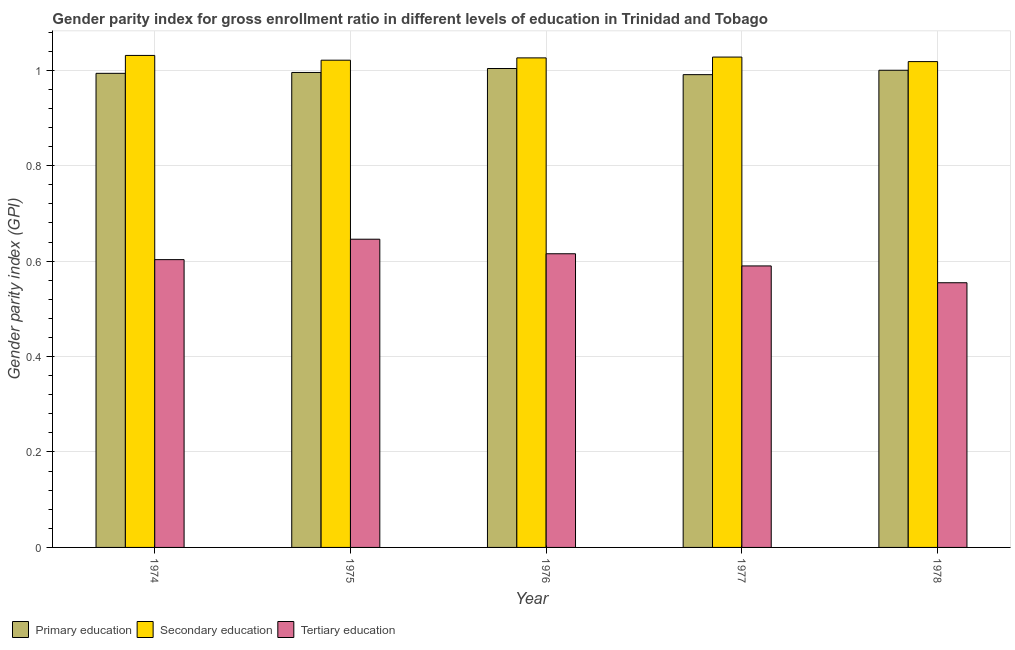How many different coloured bars are there?
Your answer should be compact. 3. Are the number of bars on each tick of the X-axis equal?
Offer a terse response. Yes. How many bars are there on the 1st tick from the left?
Ensure brevity in your answer.  3. How many bars are there on the 2nd tick from the right?
Give a very brief answer. 3. What is the label of the 5th group of bars from the left?
Your answer should be compact. 1978. In how many cases, is the number of bars for a given year not equal to the number of legend labels?
Provide a short and direct response. 0. What is the gender parity index in tertiary education in 1978?
Provide a succinct answer. 0.55. Across all years, what is the maximum gender parity index in primary education?
Keep it short and to the point. 1. Across all years, what is the minimum gender parity index in primary education?
Provide a succinct answer. 0.99. In which year was the gender parity index in primary education maximum?
Your answer should be very brief. 1976. In which year was the gender parity index in secondary education minimum?
Your answer should be very brief. 1978. What is the total gender parity index in tertiary education in the graph?
Offer a very short reply. 3.01. What is the difference between the gender parity index in primary education in 1974 and that in 1976?
Make the answer very short. -0.01. What is the difference between the gender parity index in tertiary education in 1974 and the gender parity index in primary education in 1976?
Your answer should be very brief. -0.01. What is the average gender parity index in primary education per year?
Offer a terse response. 1. What is the ratio of the gender parity index in secondary education in 1974 to that in 1977?
Your answer should be compact. 1. Is the difference between the gender parity index in secondary education in 1976 and 1977 greater than the difference between the gender parity index in primary education in 1976 and 1977?
Provide a succinct answer. No. What is the difference between the highest and the second highest gender parity index in primary education?
Ensure brevity in your answer.  0. What is the difference between the highest and the lowest gender parity index in secondary education?
Provide a short and direct response. 0.01. Is the sum of the gender parity index in primary education in 1974 and 1975 greater than the maximum gender parity index in tertiary education across all years?
Your response must be concise. Yes. What does the 3rd bar from the left in 1978 represents?
Provide a succinct answer. Tertiary education. What does the 2nd bar from the right in 1976 represents?
Provide a succinct answer. Secondary education. How many bars are there?
Ensure brevity in your answer.  15. Are all the bars in the graph horizontal?
Your response must be concise. No. What is the difference between two consecutive major ticks on the Y-axis?
Keep it short and to the point. 0.2. Are the values on the major ticks of Y-axis written in scientific E-notation?
Your answer should be very brief. No. Does the graph contain grids?
Make the answer very short. Yes. What is the title of the graph?
Offer a very short reply. Gender parity index for gross enrollment ratio in different levels of education in Trinidad and Tobago. Does "Ages 15-20" appear as one of the legend labels in the graph?
Give a very brief answer. No. What is the label or title of the X-axis?
Your response must be concise. Year. What is the label or title of the Y-axis?
Make the answer very short. Gender parity index (GPI). What is the Gender parity index (GPI) in Primary education in 1974?
Keep it short and to the point. 0.99. What is the Gender parity index (GPI) in Secondary education in 1974?
Provide a short and direct response. 1.03. What is the Gender parity index (GPI) of Tertiary education in 1974?
Your response must be concise. 0.6. What is the Gender parity index (GPI) in Secondary education in 1975?
Ensure brevity in your answer.  1.02. What is the Gender parity index (GPI) in Tertiary education in 1975?
Your answer should be compact. 0.65. What is the Gender parity index (GPI) of Secondary education in 1976?
Your answer should be compact. 1.03. What is the Gender parity index (GPI) in Tertiary education in 1976?
Make the answer very short. 0.62. What is the Gender parity index (GPI) of Primary education in 1977?
Keep it short and to the point. 0.99. What is the Gender parity index (GPI) of Secondary education in 1977?
Provide a short and direct response. 1.03. What is the Gender parity index (GPI) in Tertiary education in 1977?
Offer a very short reply. 0.59. What is the Gender parity index (GPI) in Primary education in 1978?
Offer a very short reply. 1. What is the Gender parity index (GPI) in Secondary education in 1978?
Provide a short and direct response. 1.02. What is the Gender parity index (GPI) of Tertiary education in 1978?
Offer a terse response. 0.55. Across all years, what is the maximum Gender parity index (GPI) in Primary education?
Provide a succinct answer. 1. Across all years, what is the maximum Gender parity index (GPI) in Secondary education?
Provide a succinct answer. 1.03. Across all years, what is the maximum Gender parity index (GPI) of Tertiary education?
Ensure brevity in your answer.  0.65. Across all years, what is the minimum Gender parity index (GPI) of Primary education?
Provide a succinct answer. 0.99. Across all years, what is the minimum Gender parity index (GPI) in Secondary education?
Offer a very short reply. 1.02. Across all years, what is the minimum Gender parity index (GPI) in Tertiary education?
Your answer should be compact. 0.55. What is the total Gender parity index (GPI) in Primary education in the graph?
Make the answer very short. 4.98. What is the total Gender parity index (GPI) of Secondary education in the graph?
Make the answer very short. 5.12. What is the total Gender parity index (GPI) in Tertiary education in the graph?
Provide a short and direct response. 3.01. What is the difference between the Gender parity index (GPI) of Primary education in 1974 and that in 1975?
Ensure brevity in your answer.  -0. What is the difference between the Gender parity index (GPI) in Secondary education in 1974 and that in 1975?
Ensure brevity in your answer.  0.01. What is the difference between the Gender parity index (GPI) of Tertiary education in 1974 and that in 1975?
Your answer should be compact. -0.04. What is the difference between the Gender parity index (GPI) in Primary education in 1974 and that in 1976?
Offer a terse response. -0.01. What is the difference between the Gender parity index (GPI) in Secondary education in 1974 and that in 1976?
Give a very brief answer. 0.01. What is the difference between the Gender parity index (GPI) in Tertiary education in 1974 and that in 1976?
Keep it short and to the point. -0.01. What is the difference between the Gender parity index (GPI) in Primary education in 1974 and that in 1977?
Provide a succinct answer. 0. What is the difference between the Gender parity index (GPI) in Secondary education in 1974 and that in 1977?
Offer a terse response. 0. What is the difference between the Gender parity index (GPI) in Tertiary education in 1974 and that in 1977?
Ensure brevity in your answer.  0.01. What is the difference between the Gender parity index (GPI) of Primary education in 1974 and that in 1978?
Your response must be concise. -0.01. What is the difference between the Gender parity index (GPI) in Secondary education in 1974 and that in 1978?
Your response must be concise. 0.01. What is the difference between the Gender parity index (GPI) of Tertiary education in 1974 and that in 1978?
Offer a terse response. 0.05. What is the difference between the Gender parity index (GPI) in Primary education in 1975 and that in 1976?
Offer a terse response. -0.01. What is the difference between the Gender parity index (GPI) of Secondary education in 1975 and that in 1976?
Your answer should be compact. -0. What is the difference between the Gender parity index (GPI) of Tertiary education in 1975 and that in 1976?
Your answer should be compact. 0.03. What is the difference between the Gender parity index (GPI) in Primary education in 1975 and that in 1977?
Your response must be concise. 0. What is the difference between the Gender parity index (GPI) in Secondary education in 1975 and that in 1977?
Give a very brief answer. -0.01. What is the difference between the Gender parity index (GPI) of Tertiary education in 1975 and that in 1977?
Ensure brevity in your answer.  0.06. What is the difference between the Gender parity index (GPI) in Primary education in 1975 and that in 1978?
Offer a terse response. -0. What is the difference between the Gender parity index (GPI) of Secondary education in 1975 and that in 1978?
Provide a short and direct response. 0. What is the difference between the Gender parity index (GPI) of Tertiary education in 1975 and that in 1978?
Offer a very short reply. 0.09. What is the difference between the Gender parity index (GPI) of Primary education in 1976 and that in 1977?
Provide a succinct answer. 0.01. What is the difference between the Gender parity index (GPI) in Secondary education in 1976 and that in 1977?
Give a very brief answer. -0. What is the difference between the Gender parity index (GPI) of Tertiary education in 1976 and that in 1977?
Provide a short and direct response. 0.03. What is the difference between the Gender parity index (GPI) of Primary education in 1976 and that in 1978?
Offer a terse response. 0. What is the difference between the Gender parity index (GPI) of Secondary education in 1976 and that in 1978?
Make the answer very short. 0.01. What is the difference between the Gender parity index (GPI) in Tertiary education in 1976 and that in 1978?
Ensure brevity in your answer.  0.06. What is the difference between the Gender parity index (GPI) of Primary education in 1977 and that in 1978?
Offer a very short reply. -0.01. What is the difference between the Gender parity index (GPI) of Secondary education in 1977 and that in 1978?
Offer a terse response. 0.01. What is the difference between the Gender parity index (GPI) in Tertiary education in 1977 and that in 1978?
Make the answer very short. 0.04. What is the difference between the Gender parity index (GPI) of Primary education in 1974 and the Gender parity index (GPI) of Secondary education in 1975?
Provide a short and direct response. -0.03. What is the difference between the Gender parity index (GPI) of Primary education in 1974 and the Gender parity index (GPI) of Tertiary education in 1975?
Keep it short and to the point. 0.35. What is the difference between the Gender parity index (GPI) of Secondary education in 1974 and the Gender parity index (GPI) of Tertiary education in 1975?
Your response must be concise. 0.39. What is the difference between the Gender parity index (GPI) of Primary education in 1974 and the Gender parity index (GPI) of Secondary education in 1976?
Your answer should be very brief. -0.03. What is the difference between the Gender parity index (GPI) in Primary education in 1974 and the Gender parity index (GPI) in Tertiary education in 1976?
Your response must be concise. 0.38. What is the difference between the Gender parity index (GPI) of Secondary education in 1974 and the Gender parity index (GPI) of Tertiary education in 1976?
Keep it short and to the point. 0.42. What is the difference between the Gender parity index (GPI) in Primary education in 1974 and the Gender parity index (GPI) in Secondary education in 1977?
Give a very brief answer. -0.03. What is the difference between the Gender parity index (GPI) of Primary education in 1974 and the Gender parity index (GPI) of Tertiary education in 1977?
Provide a short and direct response. 0.4. What is the difference between the Gender parity index (GPI) in Secondary education in 1974 and the Gender parity index (GPI) in Tertiary education in 1977?
Your answer should be compact. 0.44. What is the difference between the Gender parity index (GPI) of Primary education in 1974 and the Gender parity index (GPI) of Secondary education in 1978?
Keep it short and to the point. -0.02. What is the difference between the Gender parity index (GPI) of Primary education in 1974 and the Gender parity index (GPI) of Tertiary education in 1978?
Make the answer very short. 0.44. What is the difference between the Gender parity index (GPI) of Secondary education in 1974 and the Gender parity index (GPI) of Tertiary education in 1978?
Give a very brief answer. 0.48. What is the difference between the Gender parity index (GPI) of Primary education in 1975 and the Gender parity index (GPI) of Secondary education in 1976?
Your response must be concise. -0.03. What is the difference between the Gender parity index (GPI) of Primary education in 1975 and the Gender parity index (GPI) of Tertiary education in 1976?
Provide a short and direct response. 0.38. What is the difference between the Gender parity index (GPI) of Secondary education in 1975 and the Gender parity index (GPI) of Tertiary education in 1976?
Offer a terse response. 0.41. What is the difference between the Gender parity index (GPI) of Primary education in 1975 and the Gender parity index (GPI) of Secondary education in 1977?
Your answer should be very brief. -0.03. What is the difference between the Gender parity index (GPI) of Primary education in 1975 and the Gender parity index (GPI) of Tertiary education in 1977?
Give a very brief answer. 0.41. What is the difference between the Gender parity index (GPI) of Secondary education in 1975 and the Gender parity index (GPI) of Tertiary education in 1977?
Give a very brief answer. 0.43. What is the difference between the Gender parity index (GPI) of Primary education in 1975 and the Gender parity index (GPI) of Secondary education in 1978?
Your answer should be compact. -0.02. What is the difference between the Gender parity index (GPI) in Primary education in 1975 and the Gender parity index (GPI) in Tertiary education in 1978?
Make the answer very short. 0.44. What is the difference between the Gender parity index (GPI) of Secondary education in 1975 and the Gender parity index (GPI) of Tertiary education in 1978?
Your response must be concise. 0.47. What is the difference between the Gender parity index (GPI) of Primary education in 1976 and the Gender parity index (GPI) of Secondary education in 1977?
Make the answer very short. -0.02. What is the difference between the Gender parity index (GPI) of Primary education in 1976 and the Gender parity index (GPI) of Tertiary education in 1977?
Your answer should be very brief. 0.41. What is the difference between the Gender parity index (GPI) of Secondary education in 1976 and the Gender parity index (GPI) of Tertiary education in 1977?
Give a very brief answer. 0.44. What is the difference between the Gender parity index (GPI) of Primary education in 1976 and the Gender parity index (GPI) of Secondary education in 1978?
Keep it short and to the point. -0.01. What is the difference between the Gender parity index (GPI) of Primary education in 1976 and the Gender parity index (GPI) of Tertiary education in 1978?
Your response must be concise. 0.45. What is the difference between the Gender parity index (GPI) of Secondary education in 1976 and the Gender parity index (GPI) of Tertiary education in 1978?
Offer a terse response. 0.47. What is the difference between the Gender parity index (GPI) in Primary education in 1977 and the Gender parity index (GPI) in Secondary education in 1978?
Make the answer very short. -0.03. What is the difference between the Gender parity index (GPI) in Primary education in 1977 and the Gender parity index (GPI) in Tertiary education in 1978?
Keep it short and to the point. 0.44. What is the difference between the Gender parity index (GPI) of Secondary education in 1977 and the Gender parity index (GPI) of Tertiary education in 1978?
Offer a terse response. 0.47. What is the average Gender parity index (GPI) in Primary education per year?
Your answer should be compact. 1. What is the average Gender parity index (GPI) of Secondary education per year?
Give a very brief answer. 1.02. What is the average Gender parity index (GPI) of Tertiary education per year?
Give a very brief answer. 0.6. In the year 1974, what is the difference between the Gender parity index (GPI) of Primary education and Gender parity index (GPI) of Secondary education?
Your answer should be very brief. -0.04. In the year 1974, what is the difference between the Gender parity index (GPI) of Primary education and Gender parity index (GPI) of Tertiary education?
Ensure brevity in your answer.  0.39. In the year 1974, what is the difference between the Gender parity index (GPI) in Secondary education and Gender parity index (GPI) in Tertiary education?
Offer a terse response. 0.43. In the year 1975, what is the difference between the Gender parity index (GPI) of Primary education and Gender parity index (GPI) of Secondary education?
Ensure brevity in your answer.  -0.03. In the year 1975, what is the difference between the Gender parity index (GPI) of Primary education and Gender parity index (GPI) of Tertiary education?
Your answer should be very brief. 0.35. In the year 1975, what is the difference between the Gender parity index (GPI) in Secondary education and Gender parity index (GPI) in Tertiary education?
Your answer should be compact. 0.38. In the year 1976, what is the difference between the Gender parity index (GPI) in Primary education and Gender parity index (GPI) in Secondary education?
Make the answer very short. -0.02. In the year 1976, what is the difference between the Gender parity index (GPI) in Primary education and Gender parity index (GPI) in Tertiary education?
Offer a very short reply. 0.39. In the year 1976, what is the difference between the Gender parity index (GPI) of Secondary education and Gender parity index (GPI) of Tertiary education?
Your answer should be very brief. 0.41. In the year 1977, what is the difference between the Gender parity index (GPI) of Primary education and Gender parity index (GPI) of Secondary education?
Provide a short and direct response. -0.04. In the year 1977, what is the difference between the Gender parity index (GPI) in Primary education and Gender parity index (GPI) in Tertiary education?
Provide a short and direct response. 0.4. In the year 1977, what is the difference between the Gender parity index (GPI) in Secondary education and Gender parity index (GPI) in Tertiary education?
Offer a very short reply. 0.44. In the year 1978, what is the difference between the Gender parity index (GPI) of Primary education and Gender parity index (GPI) of Secondary education?
Your response must be concise. -0.02. In the year 1978, what is the difference between the Gender parity index (GPI) in Primary education and Gender parity index (GPI) in Tertiary education?
Ensure brevity in your answer.  0.45. In the year 1978, what is the difference between the Gender parity index (GPI) in Secondary education and Gender parity index (GPI) in Tertiary education?
Give a very brief answer. 0.46. What is the ratio of the Gender parity index (GPI) in Primary education in 1974 to that in 1975?
Make the answer very short. 1. What is the ratio of the Gender parity index (GPI) of Secondary education in 1974 to that in 1975?
Your answer should be compact. 1.01. What is the ratio of the Gender parity index (GPI) in Tertiary education in 1974 to that in 1975?
Offer a very short reply. 0.93. What is the ratio of the Gender parity index (GPI) in Primary education in 1974 to that in 1976?
Offer a very short reply. 0.99. What is the ratio of the Gender parity index (GPI) of Primary education in 1974 to that in 1977?
Provide a short and direct response. 1. What is the ratio of the Gender parity index (GPI) in Secondary education in 1974 to that in 1977?
Make the answer very short. 1. What is the ratio of the Gender parity index (GPI) of Tertiary education in 1974 to that in 1977?
Ensure brevity in your answer.  1.02. What is the ratio of the Gender parity index (GPI) of Secondary education in 1974 to that in 1978?
Ensure brevity in your answer.  1.01. What is the ratio of the Gender parity index (GPI) of Tertiary education in 1974 to that in 1978?
Keep it short and to the point. 1.09. What is the ratio of the Gender parity index (GPI) of Tertiary education in 1975 to that in 1976?
Keep it short and to the point. 1.05. What is the ratio of the Gender parity index (GPI) in Secondary education in 1975 to that in 1977?
Ensure brevity in your answer.  0.99. What is the ratio of the Gender parity index (GPI) in Tertiary education in 1975 to that in 1977?
Your answer should be very brief. 1.09. What is the ratio of the Gender parity index (GPI) of Primary education in 1975 to that in 1978?
Provide a succinct answer. 1. What is the ratio of the Gender parity index (GPI) of Tertiary education in 1975 to that in 1978?
Offer a terse response. 1.16. What is the ratio of the Gender parity index (GPI) in Primary education in 1976 to that in 1977?
Your answer should be very brief. 1.01. What is the ratio of the Gender parity index (GPI) in Tertiary education in 1976 to that in 1977?
Offer a terse response. 1.04. What is the ratio of the Gender parity index (GPI) of Primary education in 1976 to that in 1978?
Keep it short and to the point. 1. What is the ratio of the Gender parity index (GPI) in Secondary education in 1976 to that in 1978?
Your answer should be compact. 1.01. What is the ratio of the Gender parity index (GPI) in Tertiary education in 1976 to that in 1978?
Provide a succinct answer. 1.11. What is the ratio of the Gender parity index (GPI) of Primary education in 1977 to that in 1978?
Your answer should be compact. 0.99. What is the ratio of the Gender parity index (GPI) of Secondary education in 1977 to that in 1978?
Keep it short and to the point. 1.01. What is the ratio of the Gender parity index (GPI) of Tertiary education in 1977 to that in 1978?
Ensure brevity in your answer.  1.06. What is the difference between the highest and the second highest Gender parity index (GPI) in Primary education?
Keep it short and to the point. 0. What is the difference between the highest and the second highest Gender parity index (GPI) of Secondary education?
Give a very brief answer. 0. What is the difference between the highest and the second highest Gender parity index (GPI) in Tertiary education?
Provide a short and direct response. 0.03. What is the difference between the highest and the lowest Gender parity index (GPI) of Primary education?
Your answer should be compact. 0.01. What is the difference between the highest and the lowest Gender parity index (GPI) in Secondary education?
Ensure brevity in your answer.  0.01. What is the difference between the highest and the lowest Gender parity index (GPI) of Tertiary education?
Keep it short and to the point. 0.09. 